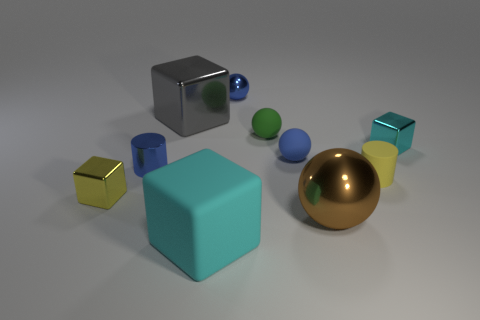There is a tiny rubber thing that is the same color as the tiny metallic cylinder; what shape is it?
Ensure brevity in your answer.  Sphere. What material is the tiny cyan block?
Give a very brief answer. Metal. Does the blue cylinder have the same material as the green thing?
Provide a short and direct response. No. What number of shiny objects are blue cylinders or tiny blue balls?
Your response must be concise. 2. The large metallic object in front of the small yellow block has what shape?
Your answer should be very brief. Sphere. What size is the gray cube that is made of the same material as the large brown object?
Your response must be concise. Large. The metal object that is in front of the tiny yellow cylinder and right of the cyan rubber block has what shape?
Offer a terse response. Sphere. There is a tiny cube on the right side of the gray metal cube; does it have the same color as the large rubber thing?
Offer a terse response. Yes. There is a metallic object behind the large gray cube; is its shape the same as the small blue matte object that is behind the small shiny cylinder?
Make the answer very short. Yes. What is the size of the cyan thing on the left side of the tiny green matte ball?
Ensure brevity in your answer.  Large. 